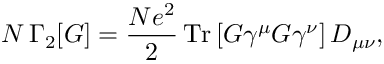Convert formula to latex. <formula><loc_0><loc_0><loc_500><loc_500>N \, \Gamma _ { 2 } [ G ] = \frac { N e ^ { 2 } } { 2 } \, T r \left [ G \gamma ^ { \mu } G \gamma ^ { \nu } \right ] D _ { \mu \nu } ,</formula> 